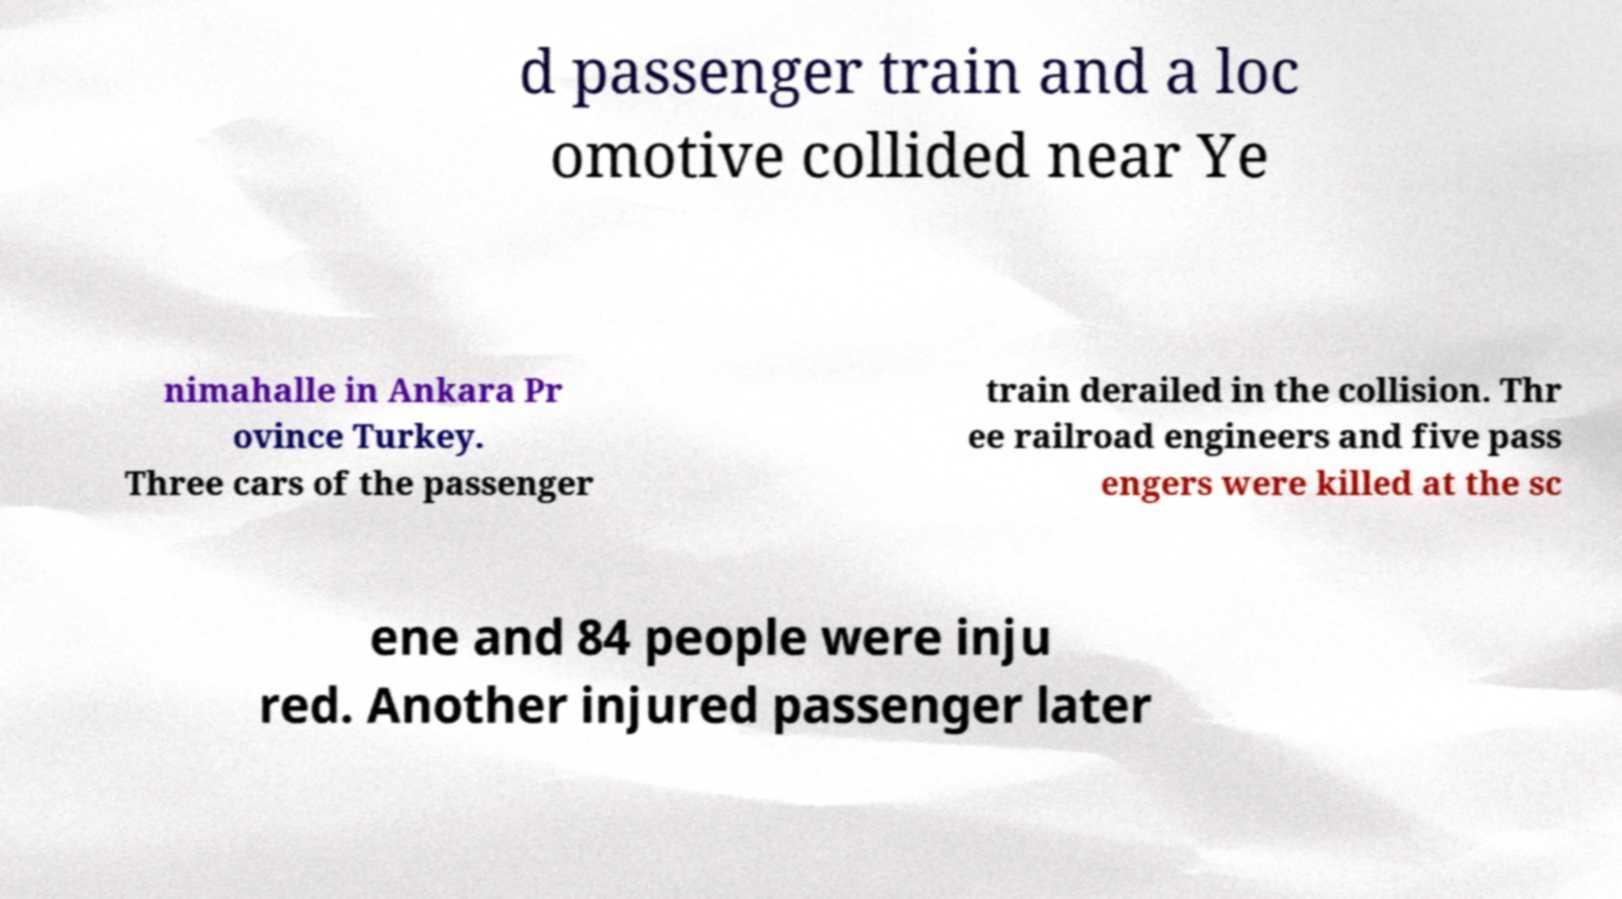Can you accurately transcribe the text from the provided image for me? d passenger train and a loc omotive collided near Ye nimahalle in Ankara Pr ovince Turkey. Three cars of the passenger train derailed in the collision. Thr ee railroad engineers and five pass engers were killed at the sc ene and 84 people were inju red. Another injured passenger later 